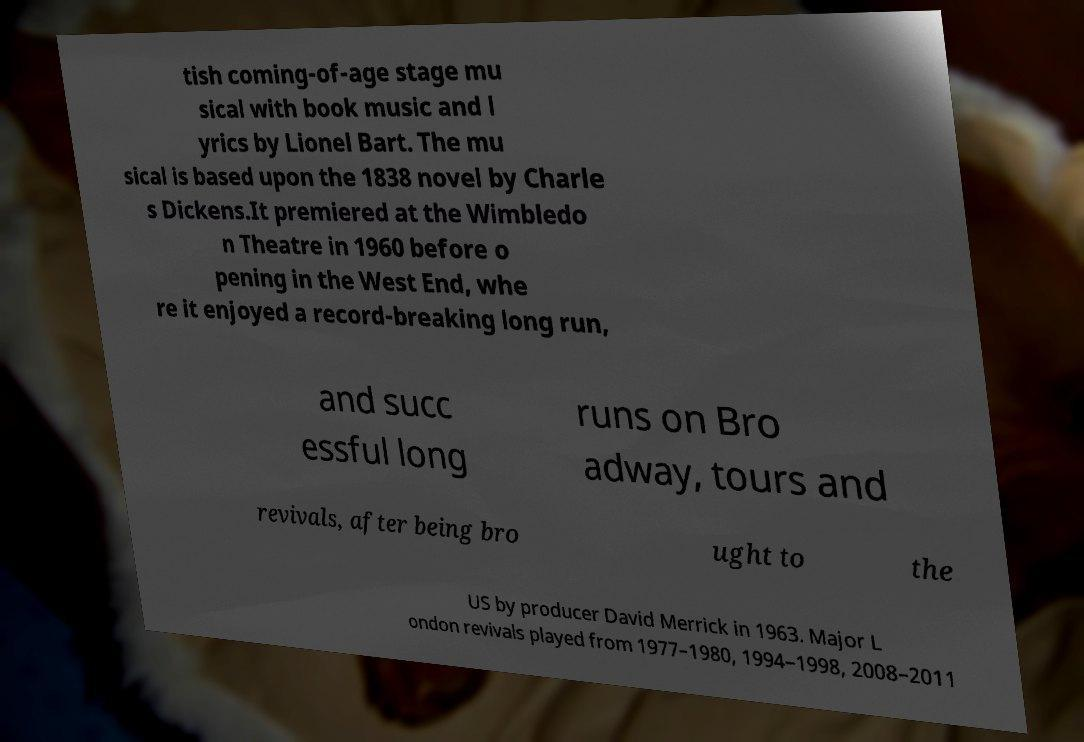Please read and relay the text visible in this image. What does it say? tish coming-of-age stage mu sical with book music and l yrics by Lionel Bart. The mu sical is based upon the 1838 novel by Charle s Dickens.It premiered at the Wimbledo n Theatre in 1960 before o pening in the West End, whe re it enjoyed a record-breaking long run, and succ essful long runs on Bro adway, tours and revivals, after being bro ught to the US by producer David Merrick in 1963. Major L ondon revivals played from 1977–1980, 1994–1998, 2008–2011 